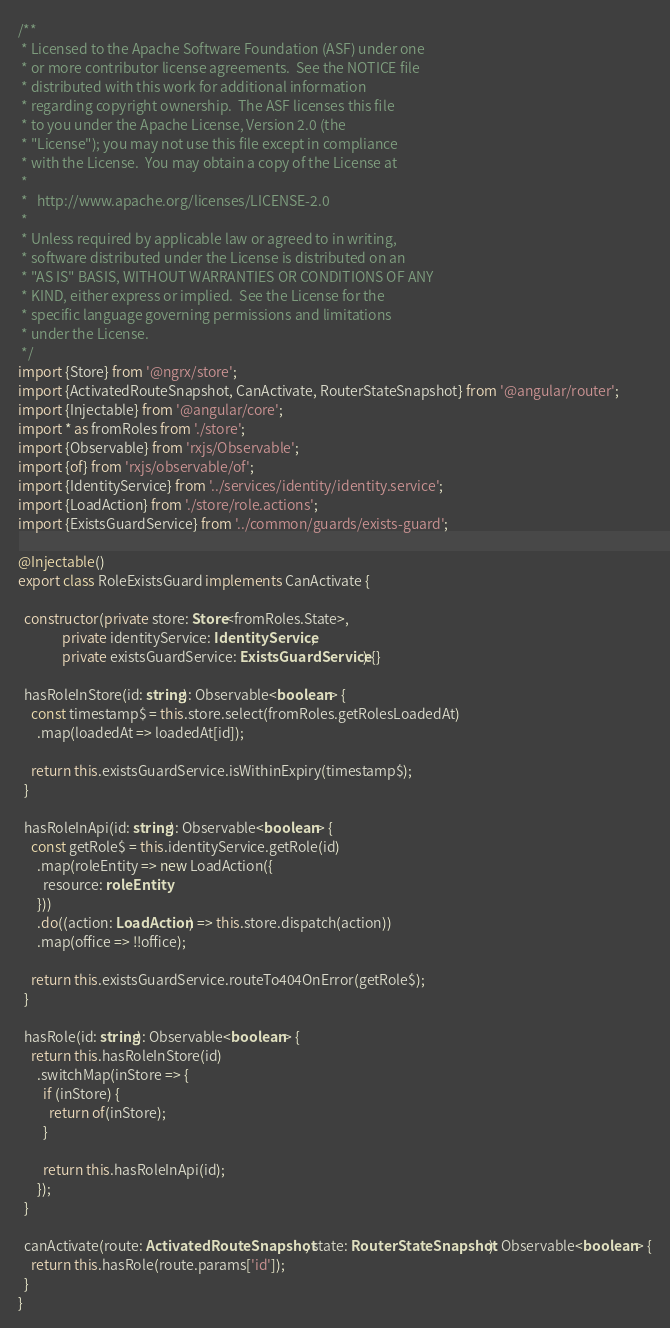<code> <loc_0><loc_0><loc_500><loc_500><_TypeScript_>/**
 * Licensed to the Apache Software Foundation (ASF) under one
 * or more contributor license agreements.  See the NOTICE file
 * distributed with this work for additional information
 * regarding copyright ownership.  The ASF licenses this file
 * to you under the Apache License, Version 2.0 (the
 * "License"); you may not use this file except in compliance
 * with the License.  You may obtain a copy of the License at
 *
 *   http://www.apache.org/licenses/LICENSE-2.0
 *
 * Unless required by applicable law or agreed to in writing,
 * software distributed under the License is distributed on an
 * "AS IS" BASIS, WITHOUT WARRANTIES OR CONDITIONS OF ANY
 * KIND, either express or implied.  See the License for the
 * specific language governing permissions and limitations
 * under the License.
 */
import {Store} from '@ngrx/store';
import {ActivatedRouteSnapshot, CanActivate, RouterStateSnapshot} from '@angular/router';
import {Injectable} from '@angular/core';
import * as fromRoles from './store';
import {Observable} from 'rxjs/Observable';
import {of} from 'rxjs/observable/of';
import {IdentityService} from '../services/identity/identity.service';
import {LoadAction} from './store/role.actions';
import {ExistsGuardService} from '../common/guards/exists-guard';

@Injectable()
export class RoleExistsGuard implements CanActivate {

  constructor(private store: Store<fromRoles.State>,
              private identityService: IdentityService,
              private existsGuardService: ExistsGuardService) {}

  hasRoleInStore(id: string): Observable<boolean> {
    const timestamp$ = this.store.select(fromRoles.getRolesLoadedAt)
      .map(loadedAt => loadedAt[id]);

    return this.existsGuardService.isWithinExpiry(timestamp$);
  }

  hasRoleInApi(id: string): Observable<boolean> {
    const getRole$ = this.identityService.getRole(id)
      .map(roleEntity => new LoadAction({
        resource: roleEntity
      }))
      .do((action: LoadAction) => this.store.dispatch(action))
      .map(office => !!office);

    return this.existsGuardService.routeTo404OnError(getRole$);
  }

  hasRole(id: string): Observable<boolean> {
    return this.hasRoleInStore(id)
      .switchMap(inStore => {
        if (inStore) {
          return of(inStore);
        }

        return this.hasRoleInApi(id);
      });
  }

  canActivate(route: ActivatedRouteSnapshot, state: RouterStateSnapshot): Observable<boolean> {
    return this.hasRole(route.params['id']);
  }
}
</code> 